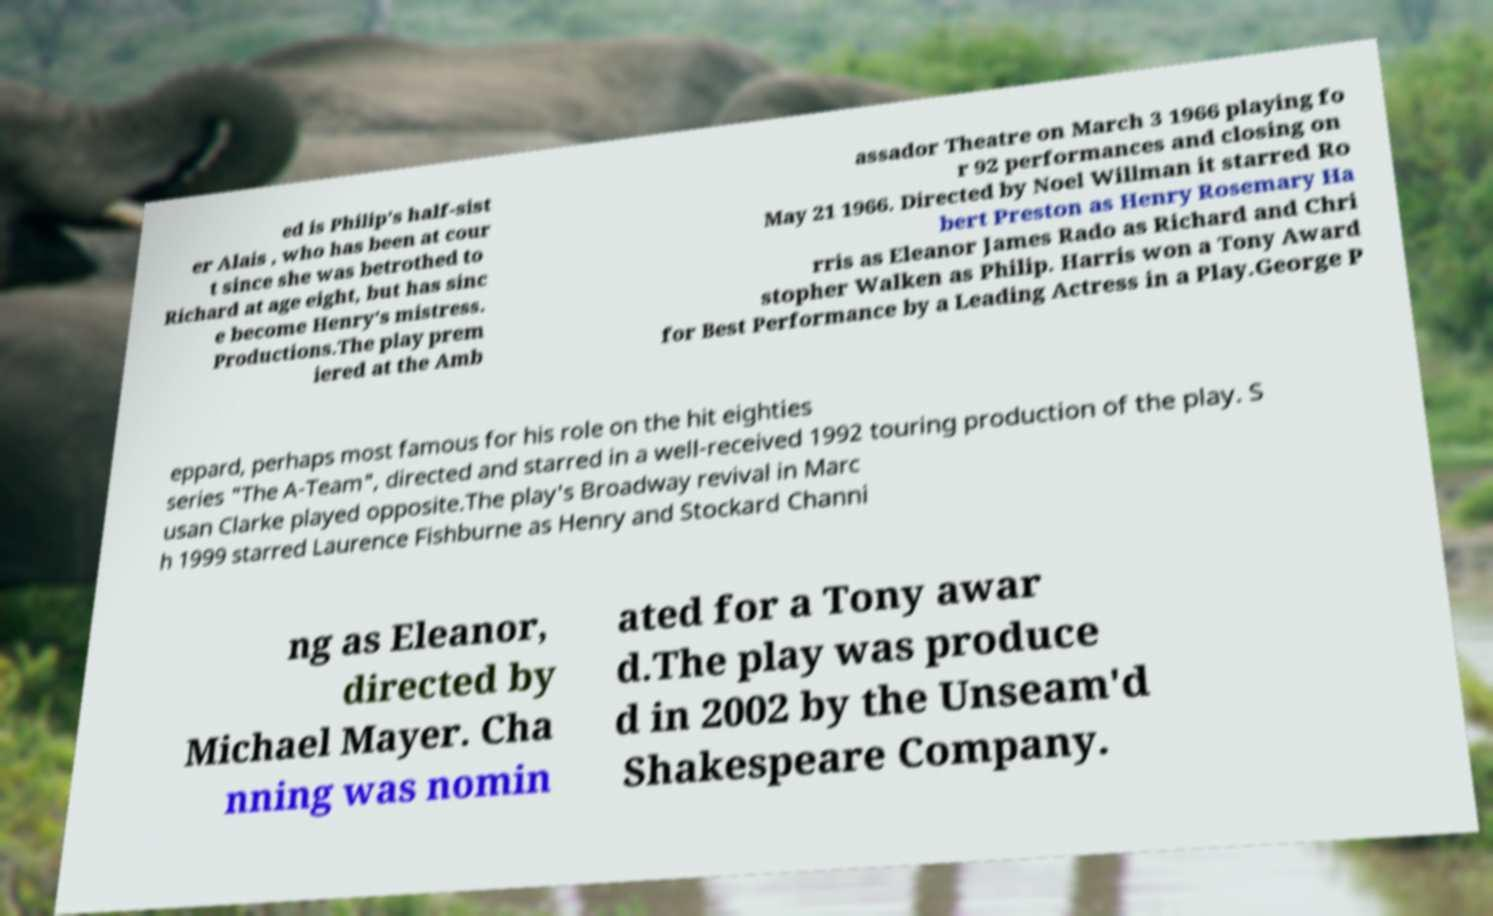Could you extract and type out the text from this image? ed is Philip's half-sist er Alais , who has been at cour t since she was betrothed to Richard at age eight, but has sinc e become Henry's mistress. Productions.The play prem iered at the Amb assador Theatre on March 3 1966 playing fo r 92 performances and closing on May 21 1966. Directed by Noel Willman it starred Ro bert Preston as Henry Rosemary Ha rris as Eleanor James Rado as Richard and Chri stopher Walken as Philip. Harris won a Tony Award for Best Performance by a Leading Actress in a Play.George P eppard, perhaps most famous for his role on the hit eighties series "The A-Team", directed and starred in a well-received 1992 touring production of the play. S usan Clarke played opposite.The play's Broadway revival in Marc h 1999 starred Laurence Fishburne as Henry and Stockard Channi ng as Eleanor, directed by Michael Mayer. Cha nning was nomin ated for a Tony awar d.The play was produce d in 2002 by the Unseam'd Shakespeare Company. 